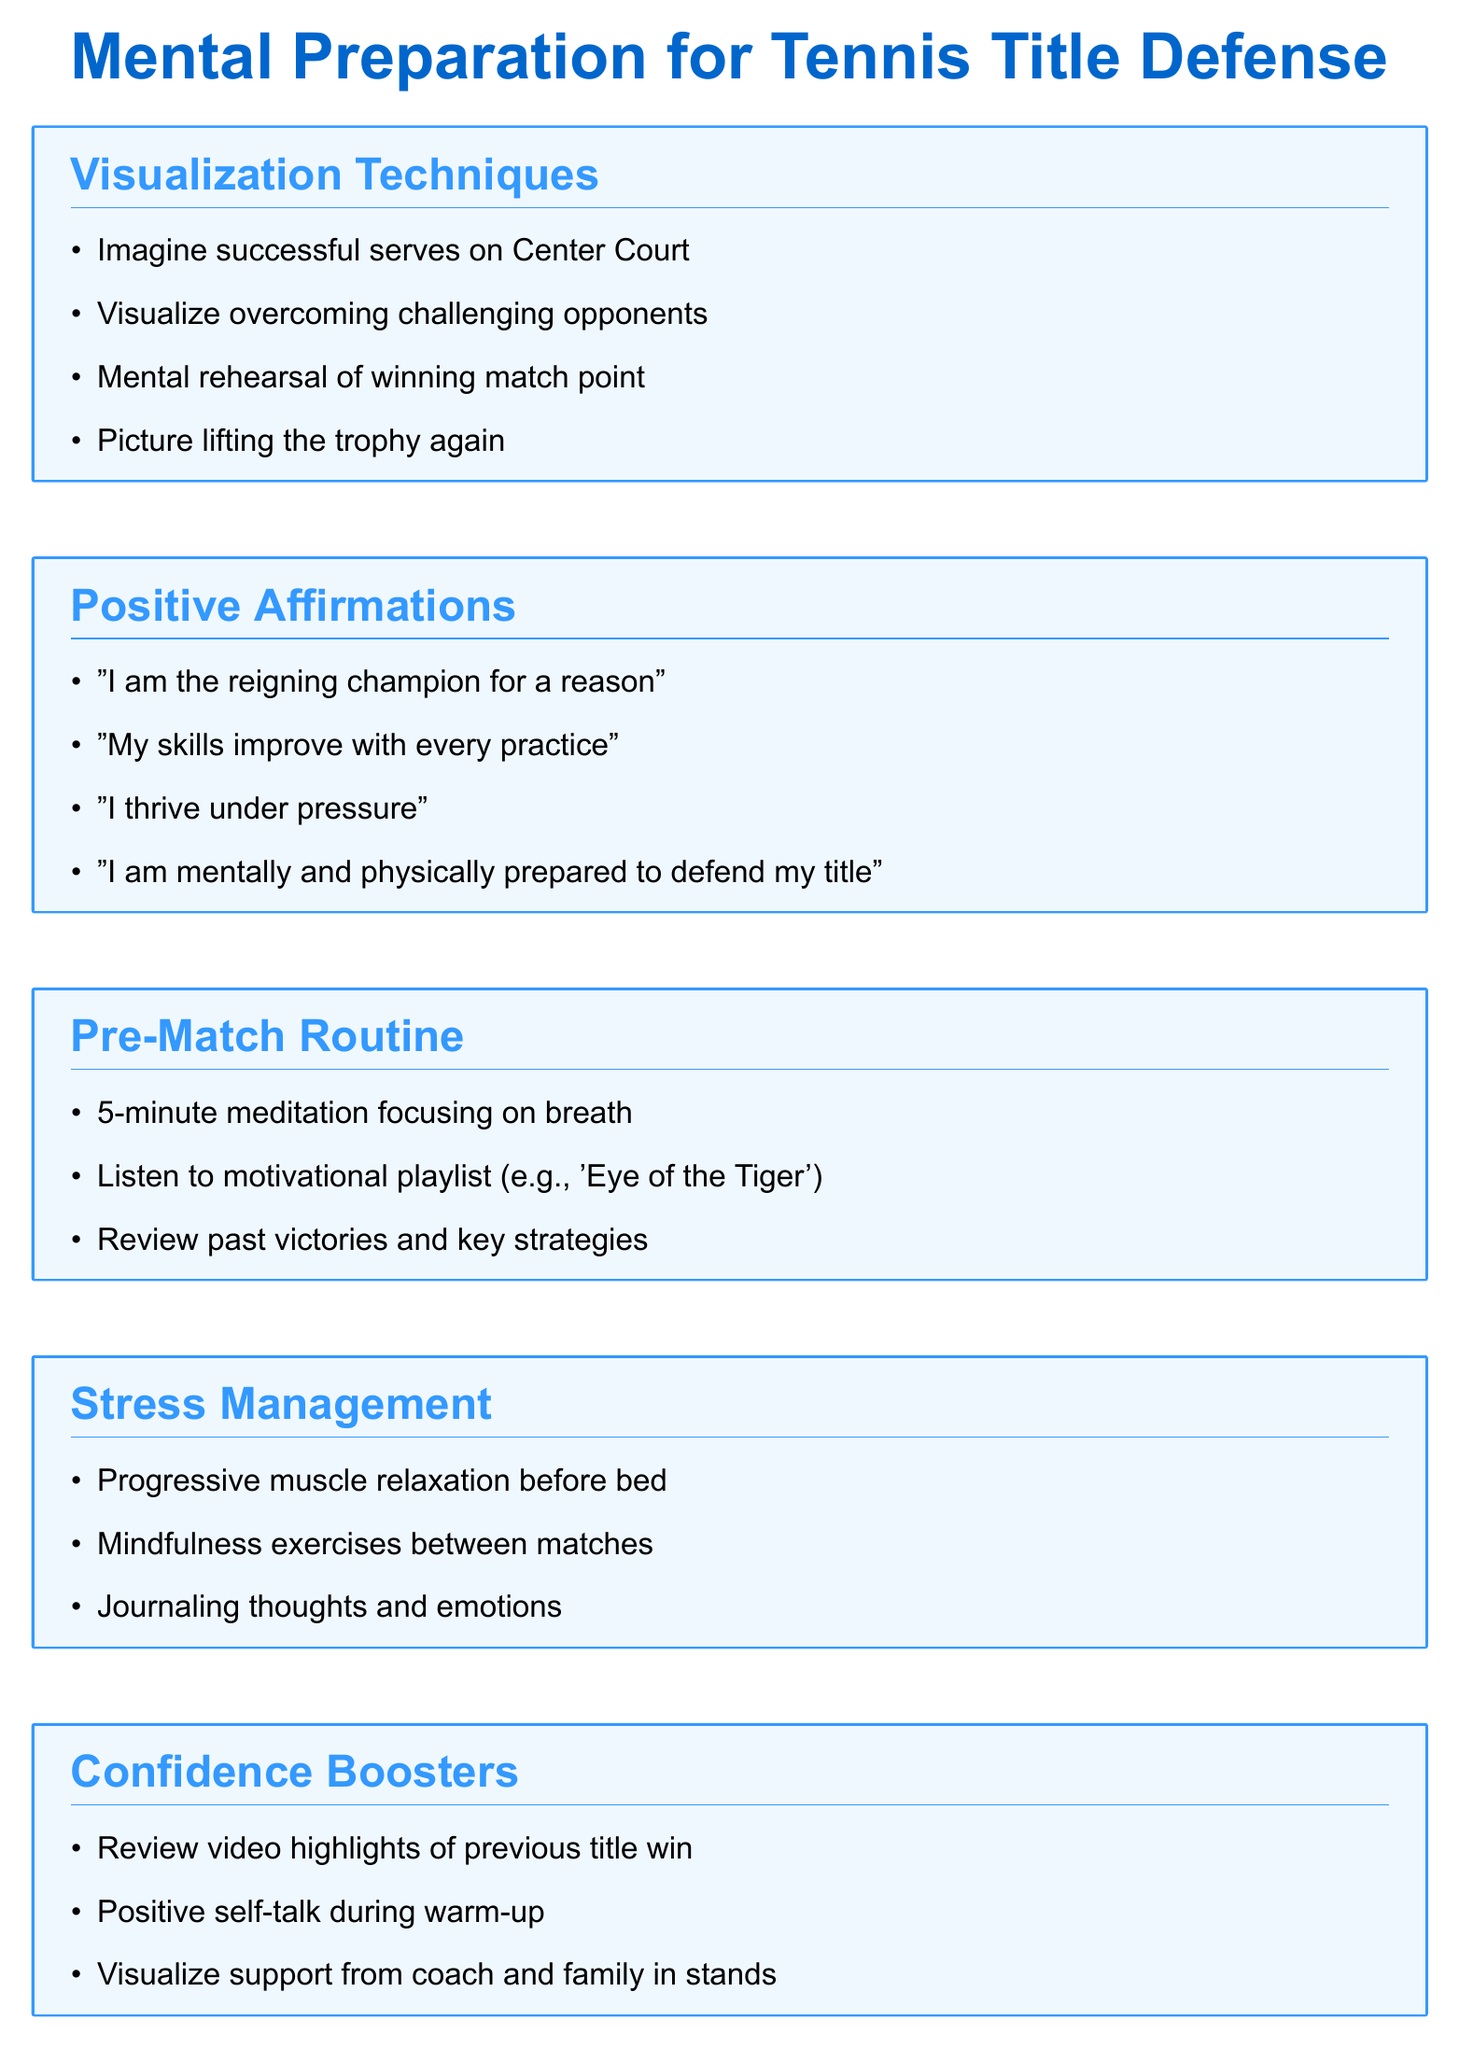What are the visualization techniques listed? The document lists several visualization techniques under the section titled "Visualization Techniques."
Answer: Imagine successful serves on Center Court, Visualize overcoming challenging opponents, Mental rehearsal of winning match point, Picture lifting the trophy again What is the first positive affirmation? The first item listed under "Positive Affirmations" is called for.
Answer: "I am the reigning champion for a reason" How many items are in the pre-match routine? The number of items in the "Pre-Match Routine" section can be counted directly from the list.
Answer: 3 What stress management technique is recommended before bed? The document specifies a technique for managing stress before sleeping.
Answer: Progressive muscle relaxation before bed Which section encourages visualization of support? The section that prompts visualization of support is identified among the listed categories.
Answer: Confidence Boosters What song is mentioned in the pre-match routine? The document provides a specific song as part of the pre-match routine.
Answer: 'Eye of the Tiger' What type of exercise is suggested between matches? The document includes a specific type of exercise designed to manage stress during match breaks.
Answer: Mindfulness exercises How does the document suggest to boost confidence? The document outlines various methods for enhancing confidence, particularly in the "Confidence Boosters" section.
Answer: Review video highlights of previous title win Which affirmation focuses on improvement? The affirmation that emphasizes improvement is specifically listed in the document.
Answer: "My skills improve with every practice" 